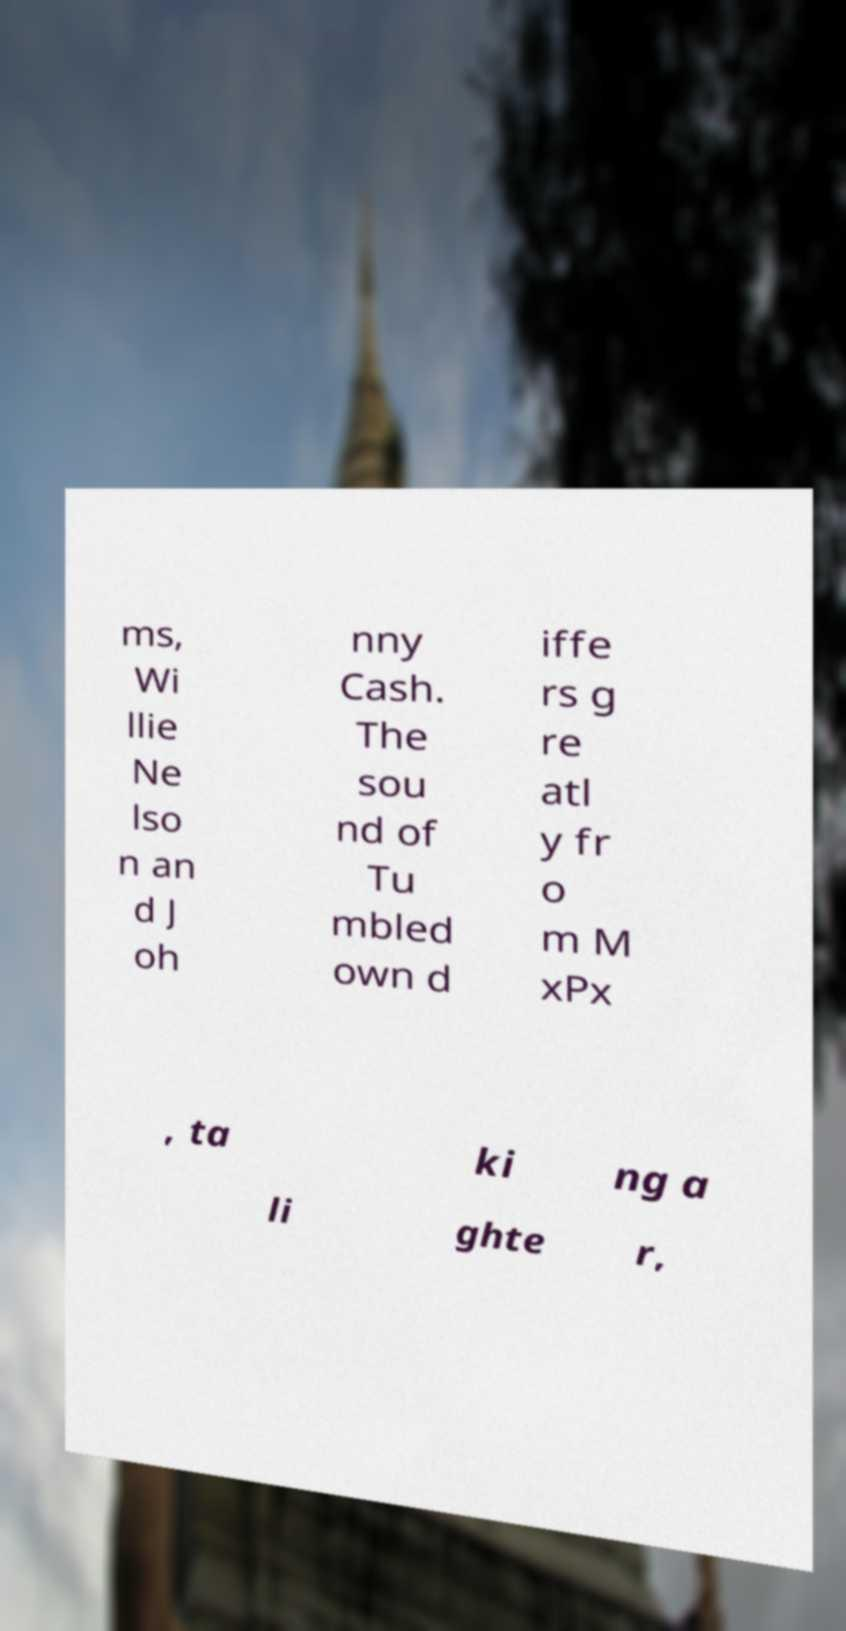Can you read and provide the text displayed in the image?This photo seems to have some interesting text. Can you extract and type it out for me? ms, Wi llie Ne lso n an d J oh nny Cash. The sou nd of Tu mbled own d iffe rs g re atl y fr o m M xPx , ta ki ng a li ghte r, 